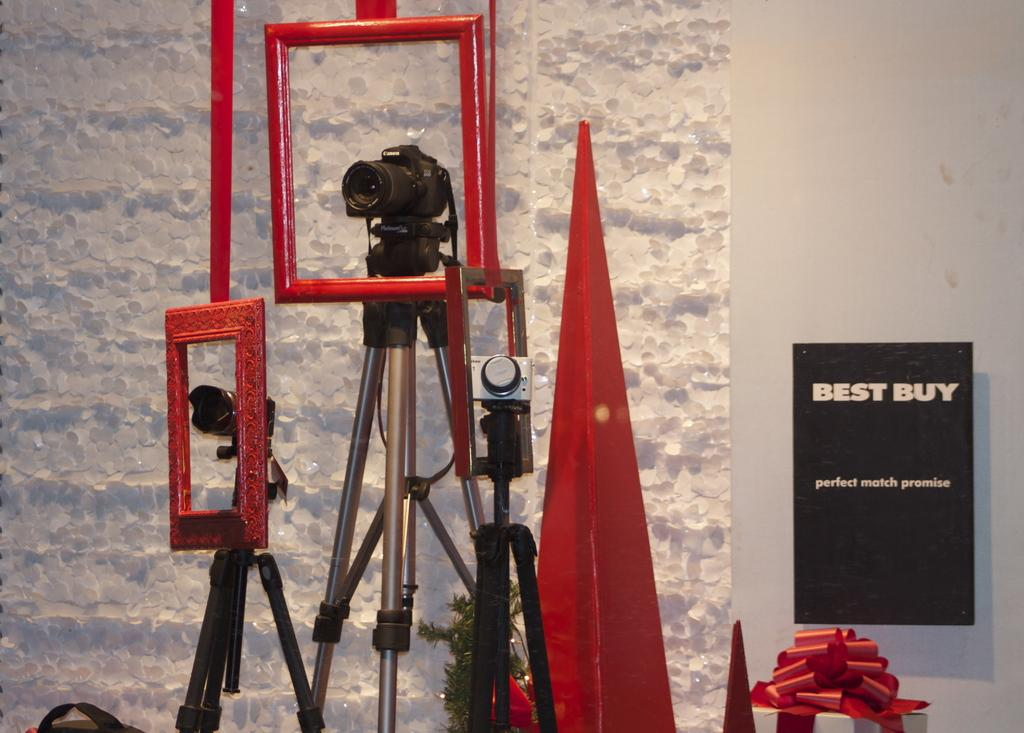What objects are placed on stands in the image? There are cameras placed on stands in the image. What can be seen in the background of the image? There is a wall and a board visible in the background. What item is present in the image that might be given as a present? There is a gift in the image. What type of decoration is visible in the image? There is a decor in the image. What objects are used to display images or artwork in the image? A: There are frames in the image. Reasoning: Let' or sound. We start by identifying the main subjects and objects in the image based on the provided facts. We then formulate questions that focus on the location and characteristics of these subjects and objects, ensuring that each question can be answered definitively with the information given. We avoid yes/no questions and ensure that the language is simple and clear. Absurd Question/Answer: Where is the library located in the image? There is no library present in the image. What type of sofa can be seen in the image? There is no sofa present in the image. Where is the van parked in the image? There is no van present in the image. 